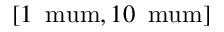<formula> <loc_0><loc_0><loc_500><loc_500>[ 1 \, \ m u m , 1 0 \, \ m u m ]</formula> 